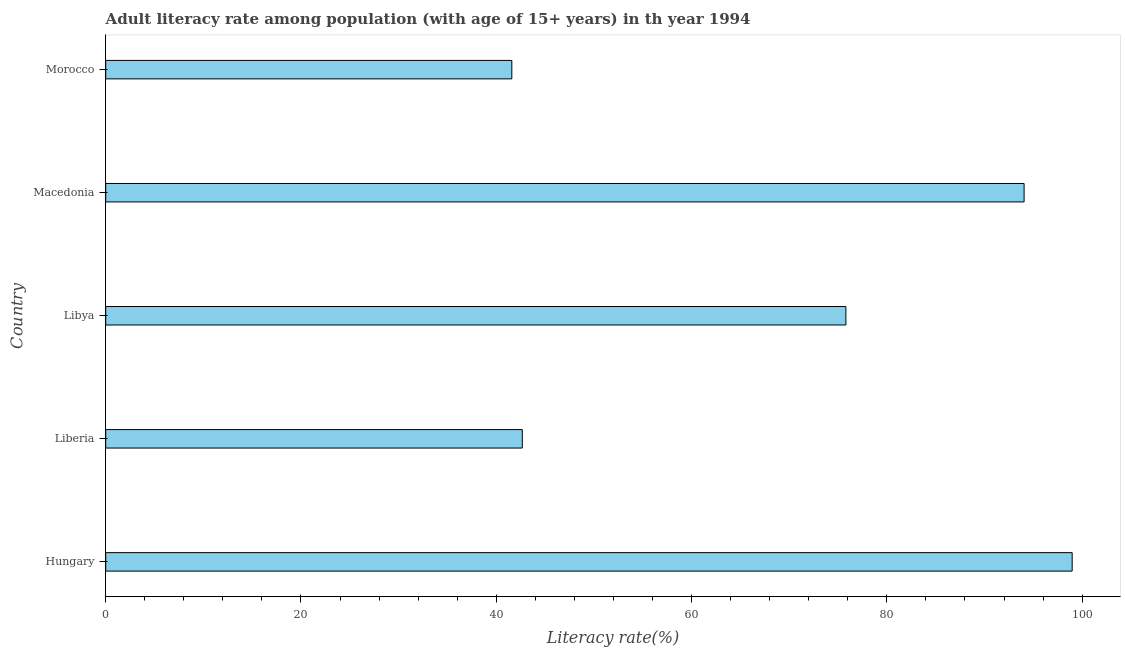Does the graph contain any zero values?
Give a very brief answer. No. Does the graph contain grids?
Ensure brevity in your answer.  No. What is the title of the graph?
Your answer should be very brief. Adult literacy rate among population (with age of 15+ years) in th year 1994. What is the label or title of the X-axis?
Provide a short and direct response. Literacy rate(%). What is the adult literacy rate in Libya?
Make the answer very short. 75.81. Across all countries, what is the maximum adult literacy rate?
Your answer should be compact. 98.98. Across all countries, what is the minimum adult literacy rate?
Your answer should be compact. 41.59. In which country was the adult literacy rate maximum?
Your answer should be very brief. Hungary. In which country was the adult literacy rate minimum?
Offer a very short reply. Morocco. What is the sum of the adult literacy rate?
Provide a short and direct response. 353.11. What is the difference between the adult literacy rate in Hungary and Libya?
Provide a short and direct response. 23.17. What is the average adult literacy rate per country?
Offer a very short reply. 70.62. What is the median adult literacy rate?
Offer a very short reply. 75.81. In how many countries, is the adult literacy rate greater than 12 %?
Make the answer very short. 5. What is the ratio of the adult literacy rate in Hungary to that in Macedonia?
Provide a short and direct response. 1.05. Is the adult literacy rate in Macedonia less than that in Morocco?
Your response must be concise. No. Is the difference between the adult literacy rate in Liberia and Libya greater than the difference between any two countries?
Ensure brevity in your answer.  No. What is the difference between the highest and the second highest adult literacy rate?
Keep it short and to the point. 4.92. What is the difference between the highest and the lowest adult literacy rate?
Give a very brief answer. 57.39. In how many countries, is the adult literacy rate greater than the average adult literacy rate taken over all countries?
Ensure brevity in your answer.  3. Are all the bars in the graph horizontal?
Your answer should be very brief. Yes. What is the difference between two consecutive major ticks on the X-axis?
Offer a very short reply. 20. What is the Literacy rate(%) of Hungary?
Your response must be concise. 98.98. What is the Literacy rate(%) of Liberia?
Your response must be concise. 42.67. What is the Literacy rate(%) of Libya?
Your answer should be compact. 75.81. What is the Literacy rate(%) of Macedonia?
Keep it short and to the point. 94.06. What is the Literacy rate(%) in Morocco?
Provide a succinct answer. 41.59. What is the difference between the Literacy rate(%) in Hungary and Liberia?
Provide a succinct answer. 56.32. What is the difference between the Literacy rate(%) in Hungary and Libya?
Your response must be concise. 23.17. What is the difference between the Literacy rate(%) in Hungary and Macedonia?
Provide a succinct answer. 4.92. What is the difference between the Literacy rate(%) in Hungary and Morocco?
Ensure brevity in your answer.  57.39. What is the difference between the Literacy rate(%) in Liberia and Libya?
Your answer should be compact. -33.14. What is the difference between the Literacy rate(%) in Liberia and Macedonia?
Provide a succinct answer. -51.39. What is the difference between the Literacy rate(%) in Liberia and Morocco?
Offer a very short reply. 1.07. What is the difference between the Literacy rate(%) in Libya and Macedonia?
Give a very brief answer. -18.25. What is the difference between the Literacy rate(%) in Libya and Morocco?
Your answer should be very brief. 34.21. What is the difference between the Literacy rate(%) in Macedonia and Morocco?
Provide a short and direct response. 52.46. What is the ratio of the Literacy rate(%) in Hungary to that in Liberia?
Ensure brevity in your answer.  2.32. What is the ratio of the Literacy rate(%) in Hungary to that in Libya?
Offer a very short reply. 1.31. What is the ratio of the Literacy rate(%) in Hungary to that in Macedonia?
Give a very brief answer. 1.05. What is the ratio of the Literacy rate(%) in Hungary to that in Morocco?
Give a very brief answer. 2.38. What is the ratio of the Literacy rate(%) in Liberia to that in Libya?
Offer a terse response. 0.56. What is the ratio of the Literacy rate(%) in Liberia to that in Macedonia?
Provide a short and direct response. 0.45. What is the ratio of the Literacy rate(%) in Liberia to that in Morocco?
Make the answer very short. 1.03. What is the ratio of the Literacy rate(%) in Libya to that in Macedonia?
Your answer should be very brief. 0.81. What is the ratio of the Literacy rate(%) in Libya to that in Morocco?
Make the answer very short. 1.82. What is the ratio of the Literacy rate(%) in Macedonia to that in Morocco?
Your response must be concise. 2.26. 